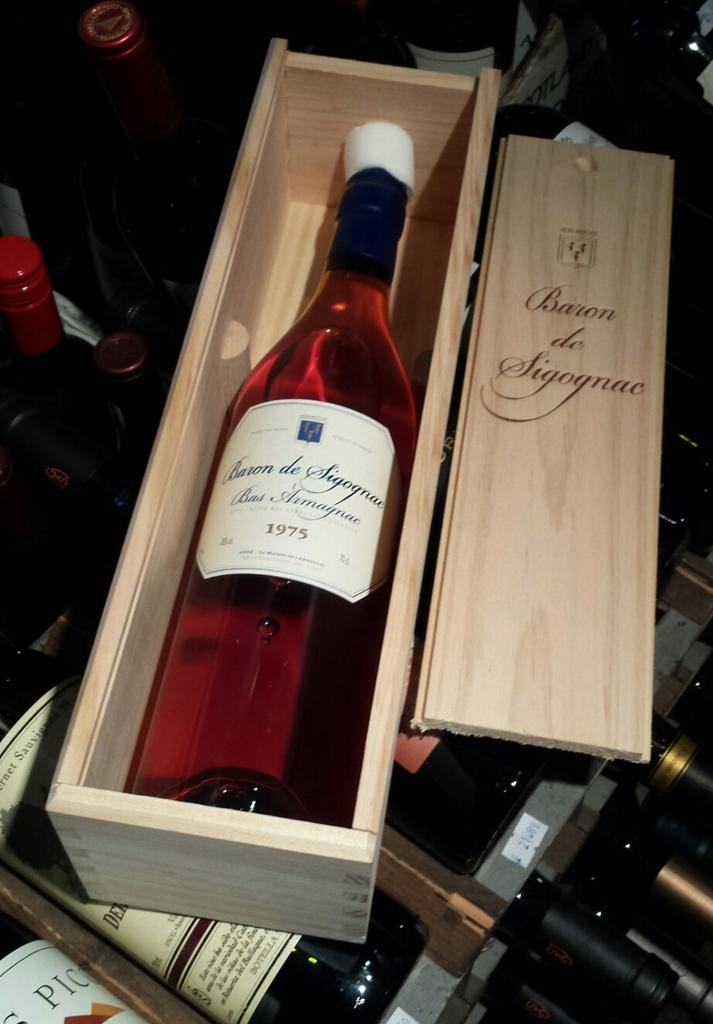<image>
Offer a succinct explanation of the picture presented. A bottle of wine from 1975 sits in a wooden box with a foam protector near the cork end. 